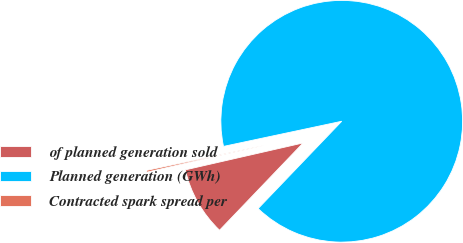<chart> <loc_0><loc_0><loc_500><loc_500><pie_chart><fcel>of planned generation sold<fcel>Planned generation (GWh)<fcel>Contracted spark spread per<nl><fcel>9.27%<fcel>90.49%<fcel>0.24%<nl></chart> 